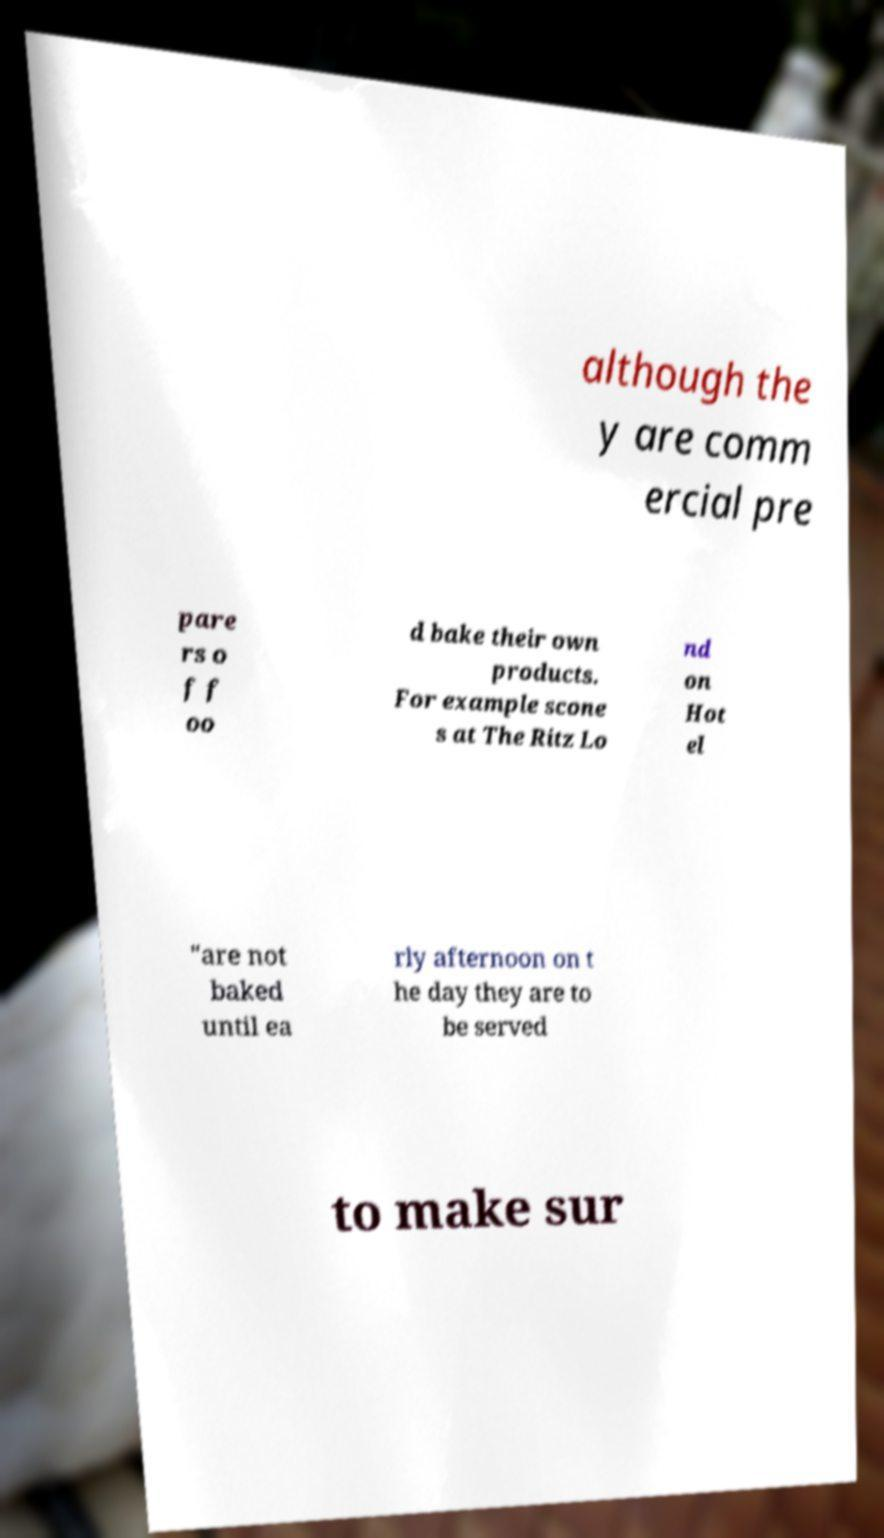Please identify and transcribe the text found in this image. although the y are comm ercial pre pare rs o f f oo d bake their own products. For example scone s at The Ritz Lo nd on Hot el "are not baked until ea rly afternoon on t he day they are to be served to make sur 